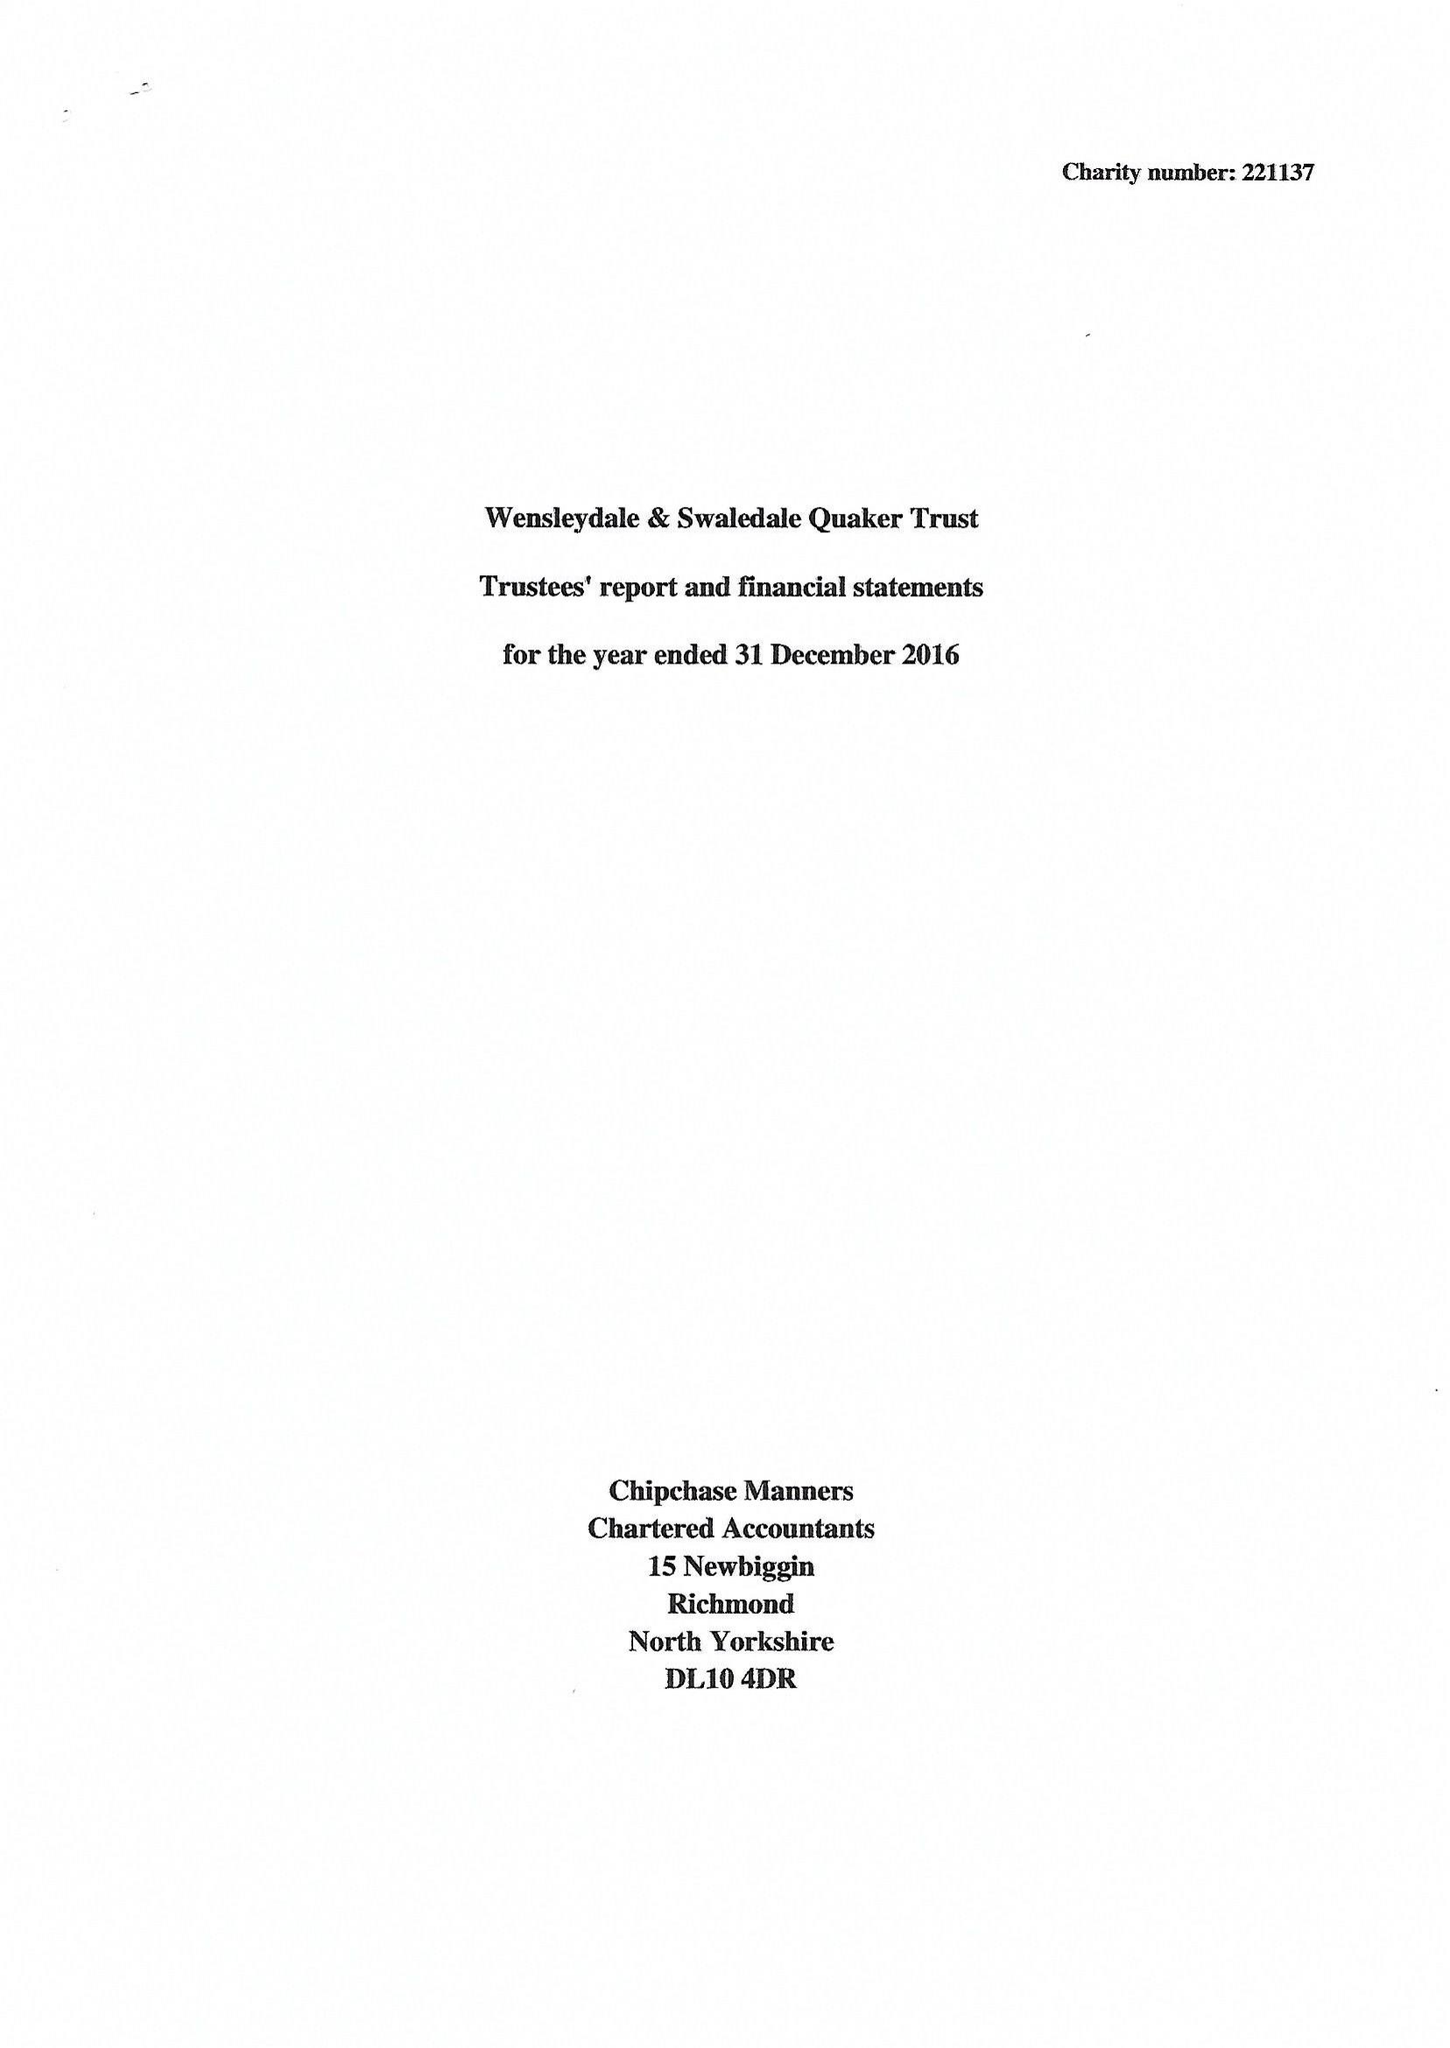What is the value for the charity_name?
Answer the question using a single word or phrase. Wensleydale and Swaledale Quaker Trust 